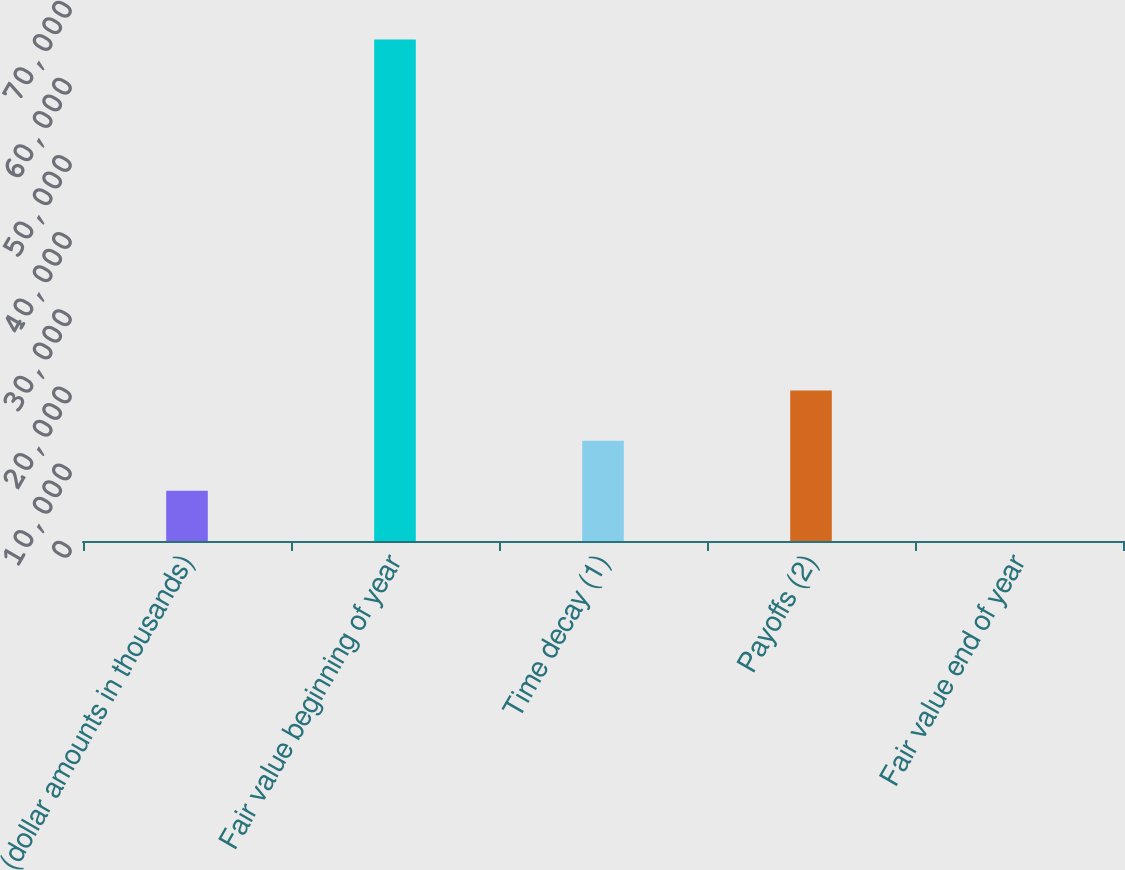Convert chart. <chart><loc_0><loc_0><loc_500><loc_500><bar_chart><fcel>(dollar amounts in thousands)<fcel>Fair value beginning of year<fcel>Time decay (1)<fcel>Payoffs (2)<fcel>Fair value end of year<nl><fcel>6502.98<fcel>65001<fcel>13002.8<fcel>19502.5<fcel>3.2<nl></chart> 